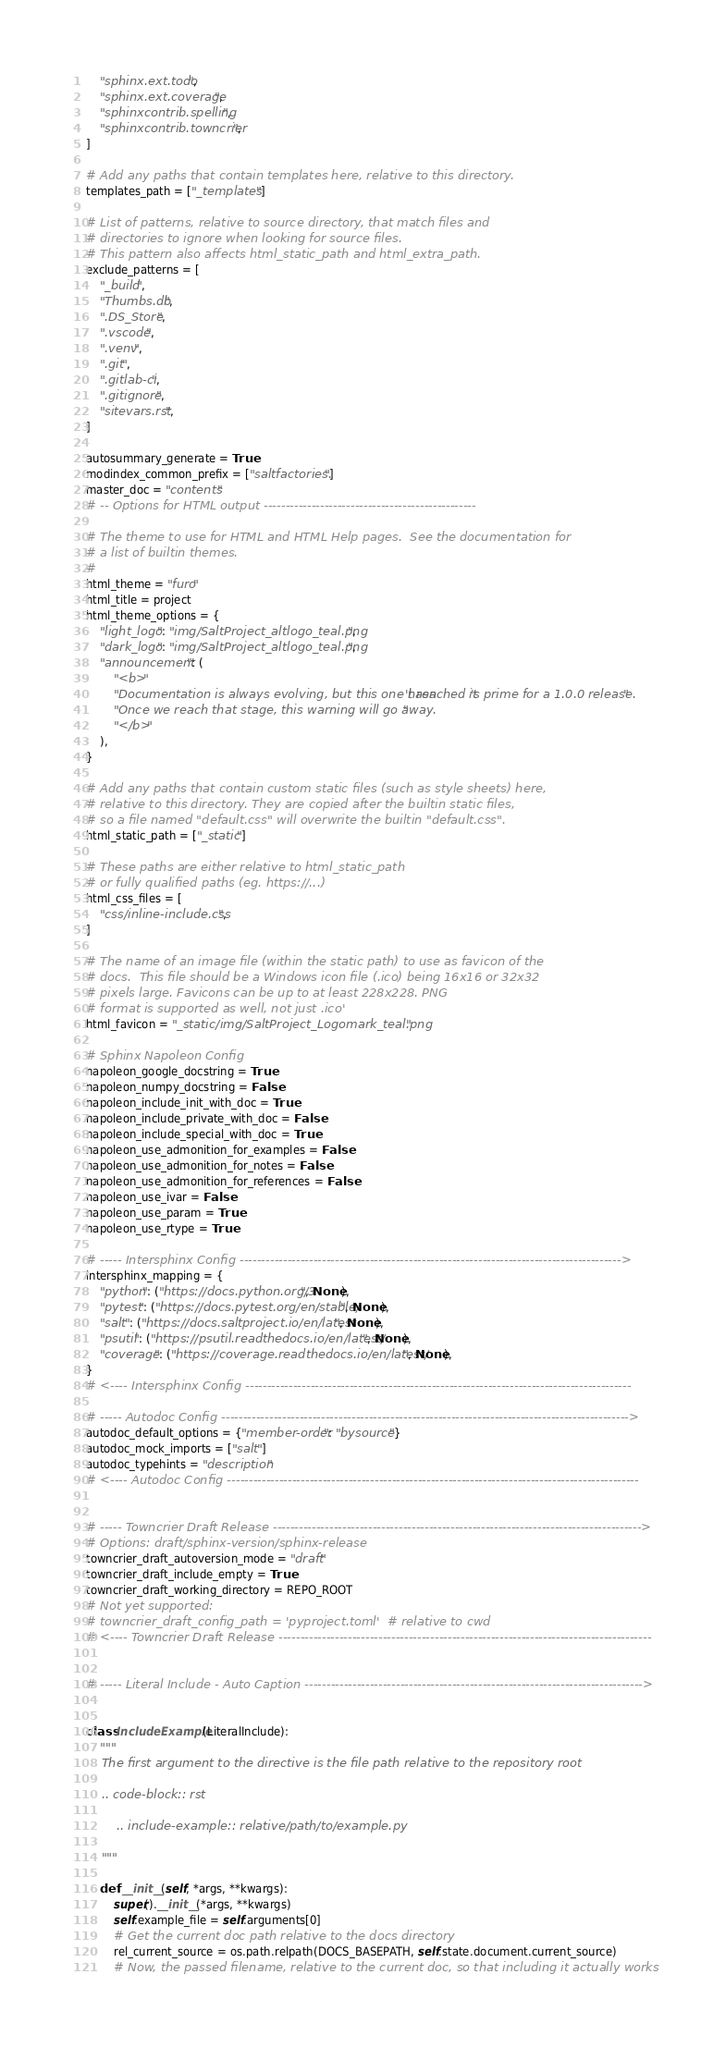<code> <loc_0><loc_0><loc_500><loc_500><_Python_>    "sphinx.ext.todo",
    "sphinx.ext.coverage",
    "sphinxcontrib.spelling",
    "sphinxcontrib.towncrier",
]

# Add any paths that contain templates here, relative to this directory.
templates_path = ["_templates"]

# List of patterns, relative to source directory, that match files and
# directories to ignore when looking for source files.
# This pattern also affects html_static_path and html_extra_path.
exclude_patterns = [
    "_build",
    "Thumbs.db",
    ".DS_Store",
    ".vscode",
    ".venv",
    ".git",
    ".gitlab-ci",
    ".gitignore",
    "sitevars.rst",
]

autosummary_generate = True
modindex_common_prefix = ["saltfactories."]
master_doc = "contents"
# -- Options for HTML output -------------------------------------------------

# The theme to use for HTML and HTML Help pages.  See the documentation for
# a list of builtin themes.
#
html_theme = "furo"
html_title = project
html_theme_options = {
    "light_logo": "img/SaltProject_altlogo_teal.png",
    "dark_logo": "img/SaltProject_altlogo_teal.png",
    "announcement": (
        "<b>"
        "Documentation is always evolving, but this one hasn't reached it's prime for a 1.0.0 release. "
        "Once we reach that stage, this warning will go away."
        "</b>"
    ),
}

# Add any paths that contain custom static files (such as style sheets) here,
# relative to this directory. They are copied after the builtin static files,
# so a file named "default.css" will overwrite the builtin "default.css".
html_static_path = ["_static"]

# These paths are either relative to html_static_path
# or fully qualified paths (eg. https://...)
html_css_files = [
    "css/inline-include.css",
]

# The name of an image file (within the static path) to use as favicon of the
# docs.  This file should be a Windows icon file (.ico) being 16x16 or 32x32
# pixels large. Favicons can be up to at least 228x228. PNG
# format is supported as well, not just .ico'
html_favicon = "_static/img/SaltProject_Logomark_teal.png"

# Sphinx Napoleon Config
napoleon_google_docstring = True
napoleon_numpy_docstring = False
napoleon_include_init_with_doc = True
napoleon_include_private_with_doc = False
napoleon_include_special_with_doc = True
napoleon_use_admonition_for_examples = False
napoleon_use_admonition_for_notes = False
napoleon_use_admonition_for_references = False
napoleon_use_ivar = False
napoleon_use_param = True
napoleon_use_rtype = True

# ----- Intersphinx Config ---------------------------------------------------------------------------------------->
intersphinx_mapping = {
    "python": ("https://docs.python.org/3", None),
    "pytest": ("https://docs.pytest.org/en/stable/", None),
    "salt": ("https://docs.saltproject.io/en/latest", None),
    "psutil": ("https://psutil.readthedocs.io/en/latest/", None),
    "coverage": ("https://coverage.readthedocs.io/en/latest/", None),
}
# <---- Intersphinx Config -----------------------------------------------------------------------------------------

# ----- Autodoc Config ---------------------------------------------------------------------------------------------->
autodoc_default_options = {"member-order": "bysource"}
autodoc_mock_imports = ["salt"]
autodoc_typehints = "description"
# <---- Autodoc Config -----------------------------------------------------------------------------------------------


# ----- Towncrier Draft Release ------------------------------------------------------------------------------------->
# Options: draft/sphinx-version/sphinx-release
towncrier_draft_autoversion_mode = "draft"
towncrier_draft_include_empty = True
towncrier_draft_working_directory = REPO_ROOT
# Not yet supported:
# towncrier_draft_config_path = 'pyproject.toml'  # relative to cwd
# <---- Towncrier Draft Release --------------------------------------------------------------------------------------


# ----- Literal Include - Auto Caption ------------------------------------------------------------------------------>


class IncludeExample(LiteralInclude):
    """
    The first argument to the directive is the file path relative to the repository root

    .. code-block:: rst

        .. include-example:: relative/path/to/example.py

    """

    def __init__(self, *args, **kwargs):
        super().__init__(*args, **kwargs)
        self.example_file = self.arguments[0]
        # Get the current doc path relative to the docs directory
        rel_current_source = os.path.relpath(DOCS_BASEPATH, self.state.document.current_source)
        # Now, the passed filename, relative to the current doc, so that including it actually works</code> 